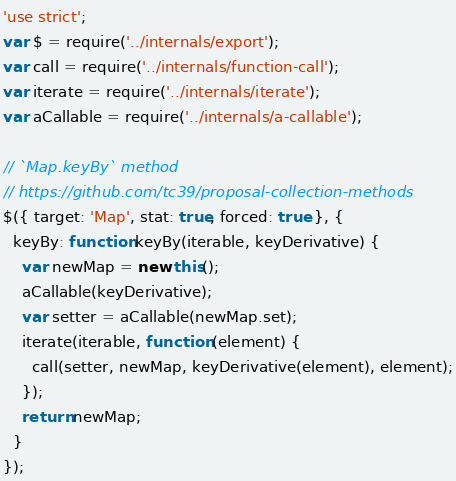<code> <loc_0><loc_0><loc_500><loc_500><_JavaScript_>'use strict';
var $ = require('../internals/export');
var call = require('../internals/function-call');
var iterate = require('../internals/iterate');
var aCallable = require('../internals/a-callable');

// `Map.keyBy` method
// https://github.com/tc39/proposal-collection-methods
$({ target: 'Map', stat: true, forced: true }, {
  keyBy: function keyBy(iterable, keyDerivative) {
    var newMap = new this();
    aCallable(keyDerivative);
    var setter = aCallable(newMap.set);
    iterate(iterable, function (element) {
      call(setter, newMap, keyDerivative(element), element);
    });
    return newMap;
  }
});
</code> 